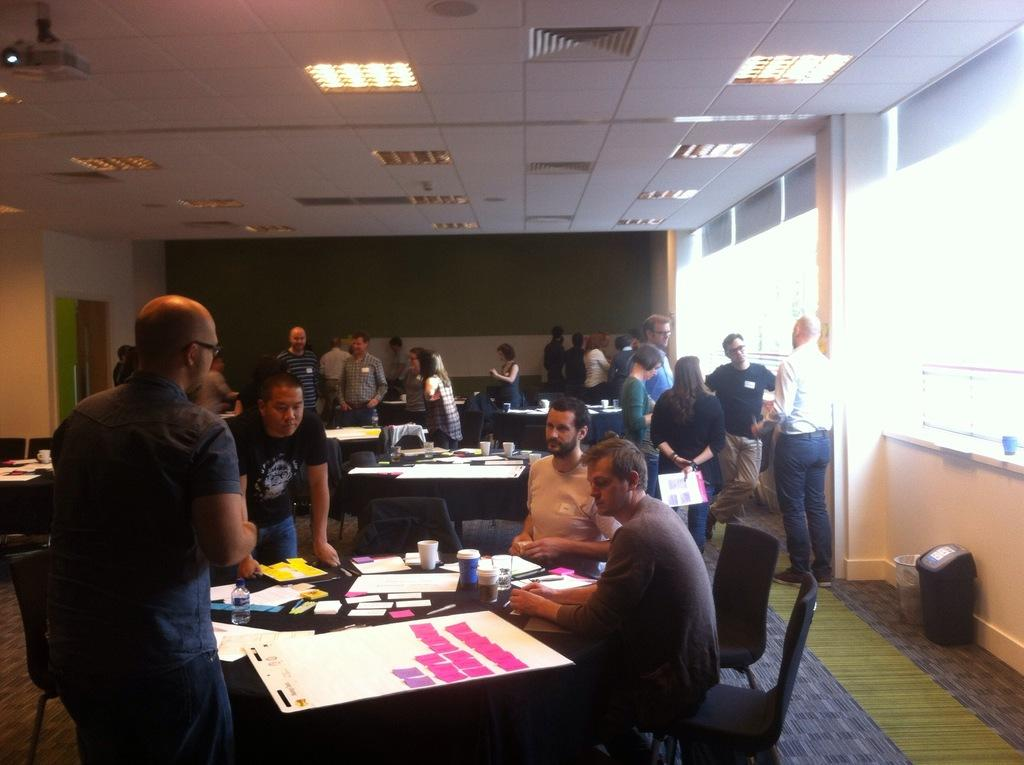What is happening with the group of people in the image? The group of people is sitting around a table. What is on the table with the people? There are papers on the table. Where is the person standing in the image? The person is standing in the left corner. What is happening in front of the standing person? There is another group of people in front of the standing person. Can you tell me how many hens are present in the image? There are no hens present in the image. What type of hydrant is visible in the image? There is no hydrant present in the image. 